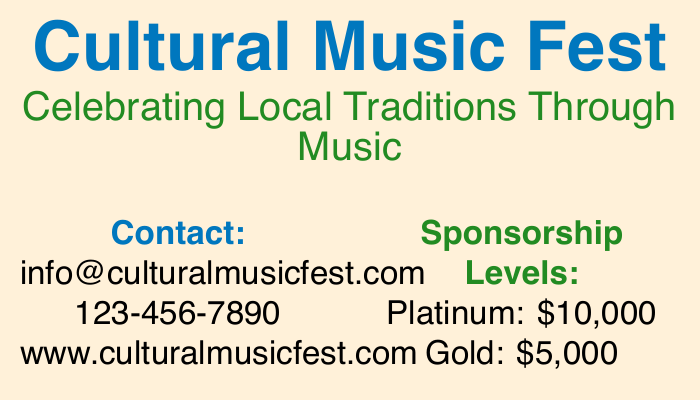What is the name of the festival? The name of the festival is prominently displayed at the top of the document.
Answer: Cultural Music Fest What is the email contact for the festival? The email for further contact is listed in the contact section of the document.
Answer: info@culturalmusicfest.com What is the highest sponsorship level? The document specifies sponsorship levels, with Platinum being the highest.
Answer: Platinum How much is the Gold sponsorship? The Gold sponsorship amount is explicitly mentioned in the sponsorship details.
Answer: $5,000 What color is used for the festival's tagline? The color used for the tagline is mentioned in the text referring to its appearance.
Answer: Forest Green What type of activities are mentioned for the festival? The document highlights several activities available at the festival, based on its content.
Answer: live performances, workshops, and more How many sponsorship levels are listed? The total number of sponsorship levels can be counted in the sponsorship details section.
Answer: 4 What is the sponsorship amount for the Community level? The document provides specific figures for each sponsorship level, including Community.
Answer: $1,000 What is the website for the Cultural Music Fest? The website is clearly listed in the contact section of the document.
Answer: www.culturalmusicfest.com 